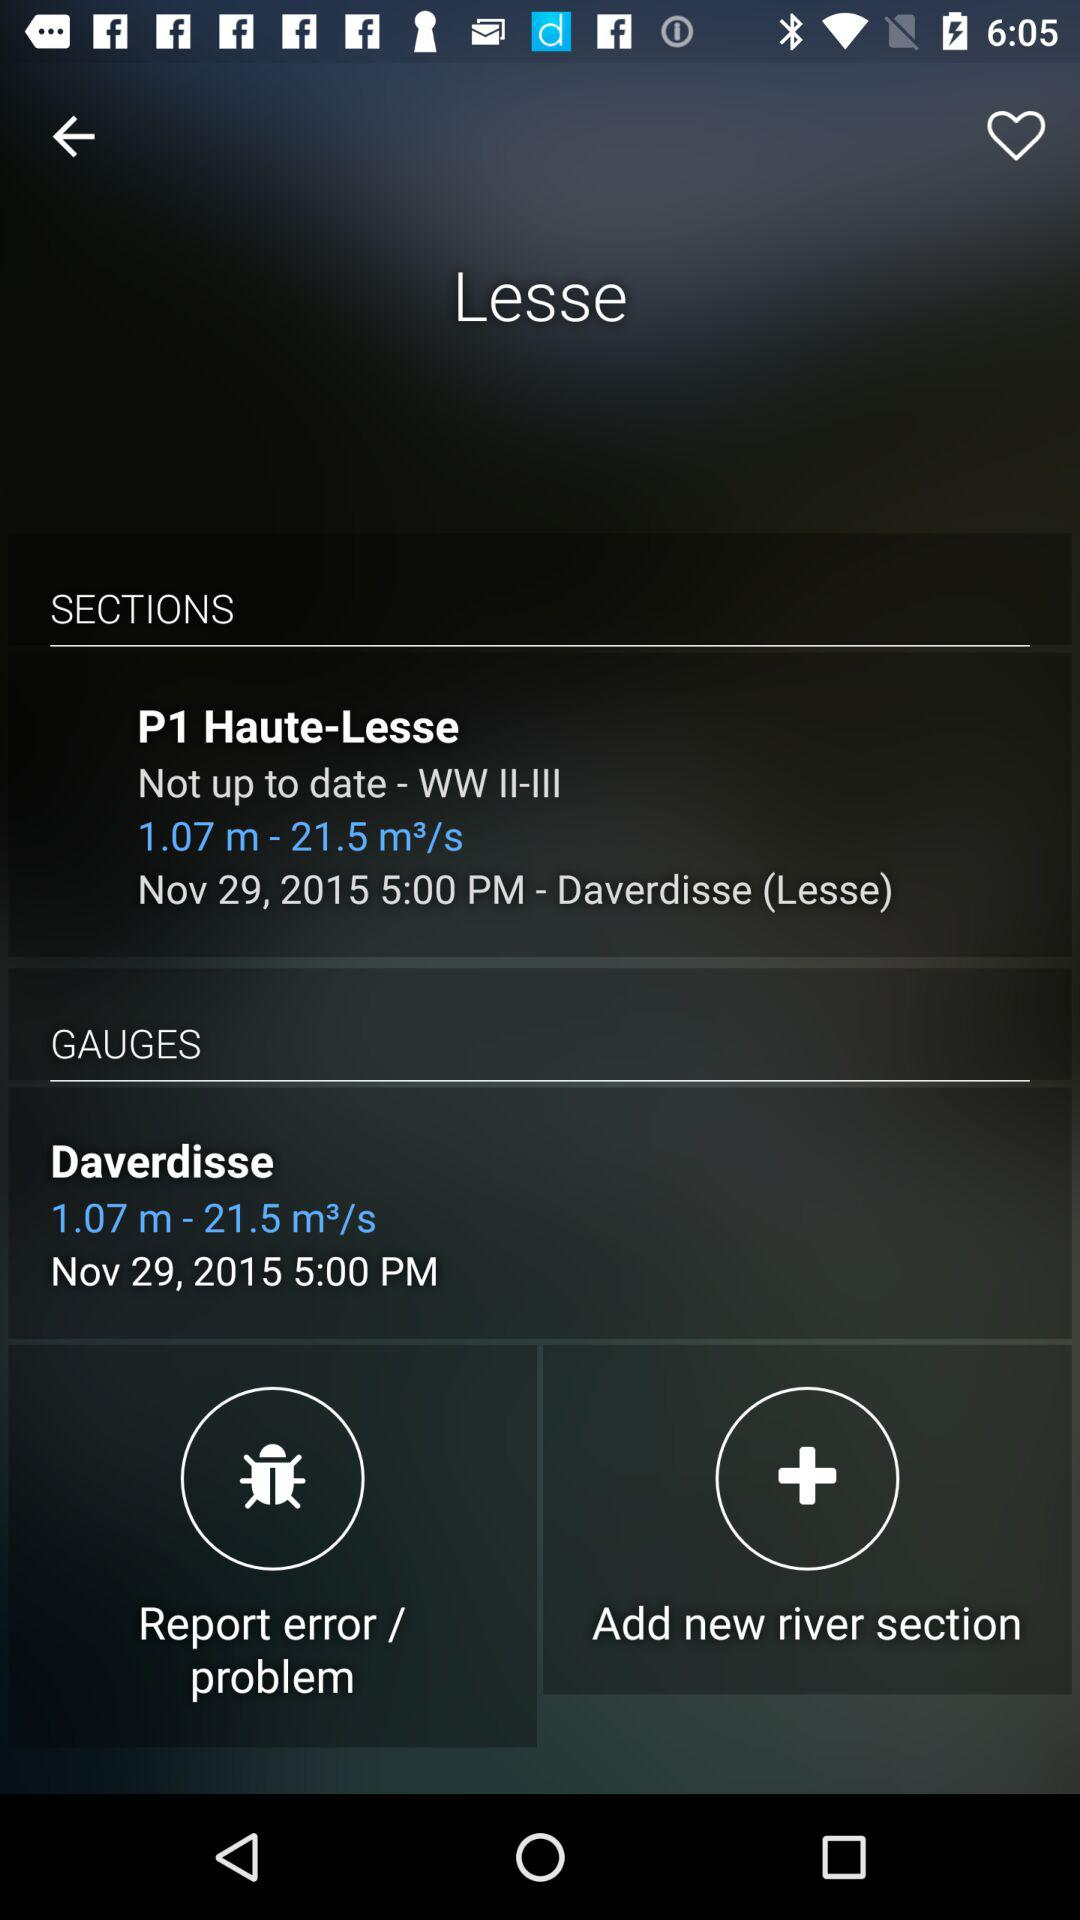On what date was "P1 Haute-Lesse" updated? "P1 Haute-Lesse" was updated on November 29, 2015. 